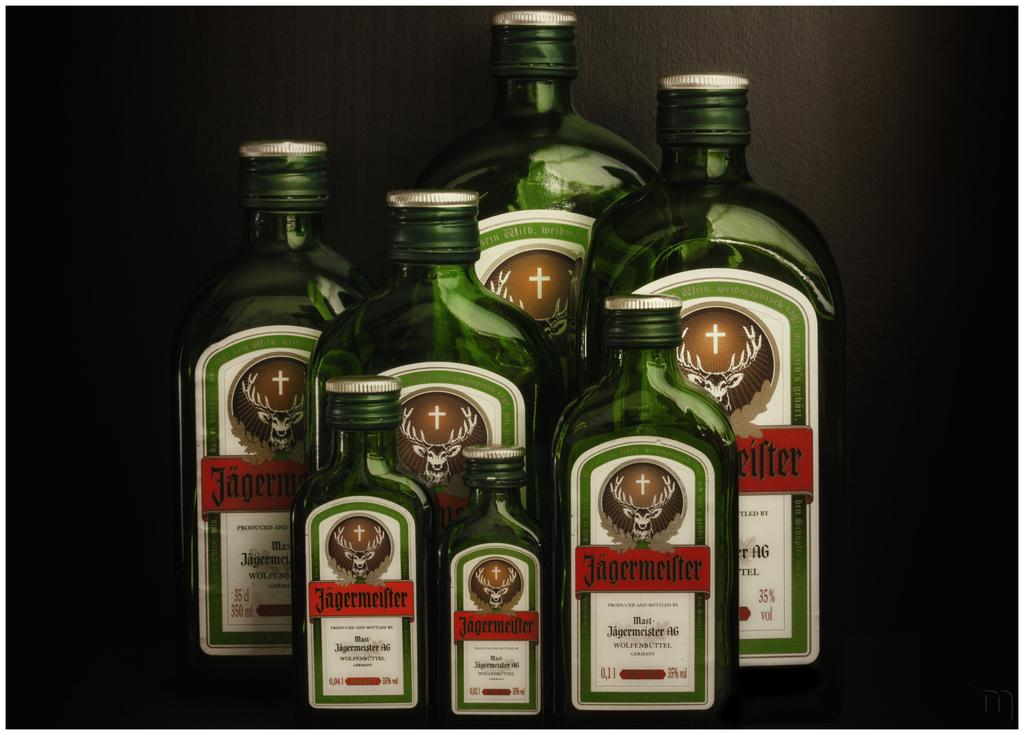Provide a one-sentence caption for the provided image. a set of various sizes of Jagermeifter liquor bottles displayed. 